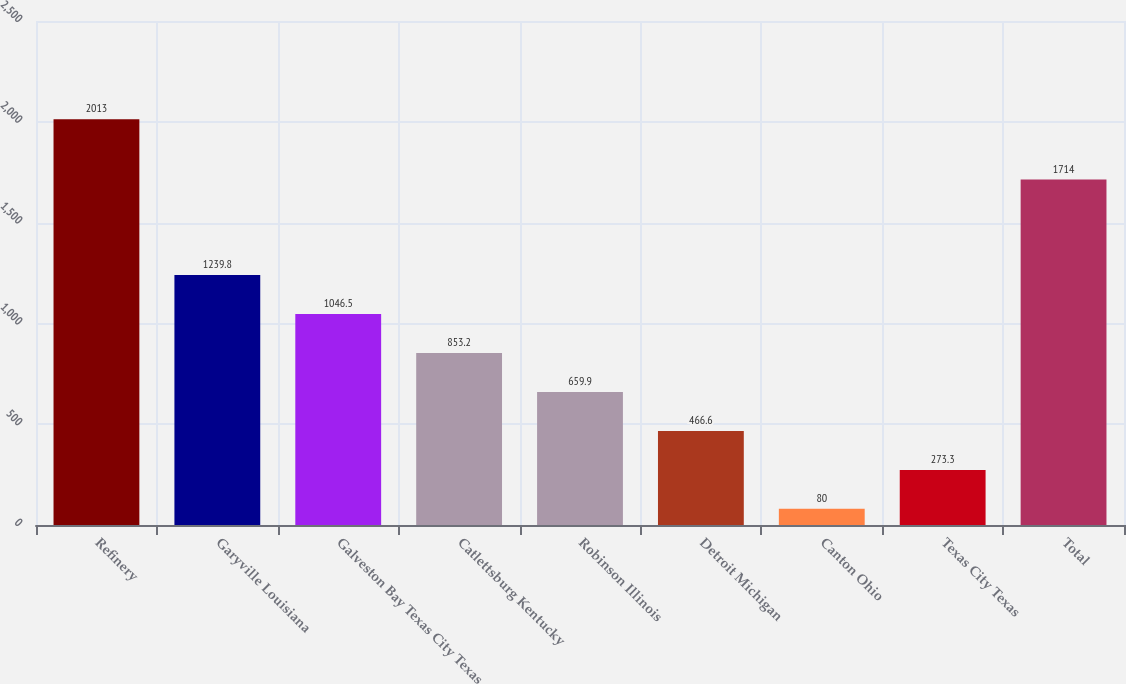Convert chart. <chart><loc_0><loc_0><loc_500><loc_500><bar_chart><fcel>Refinery<fcel>Garyville Louisiana<fcel>Galveston Bay Texas City Texas<fcel>Catlettsburg Kentucky<fcel>Robinson Illinois<fcel>Detroit Michigan<fcel>Canton Ohio<fcel>Texas City Texas<fcel>Total<nl><fcel>2013<fcel>1239.8<fcel>1046.5<fcel>853.2<fcel>659.9<fcel>466.6<fcel>80<fcel>273.3<fcel>1714<nl></chart> 